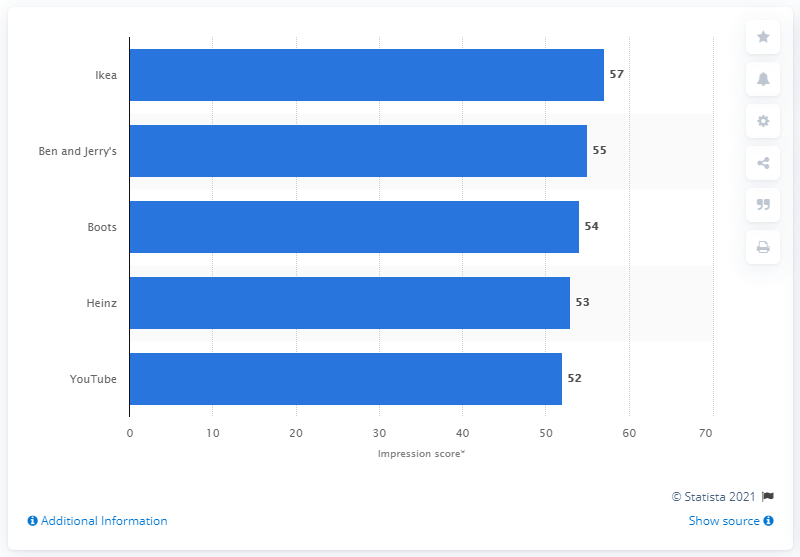Draw attention to some important aspects in this diagram. Ikea's impression score was 57 out of 100, indicating a generally positive perception but with room for improvement. 